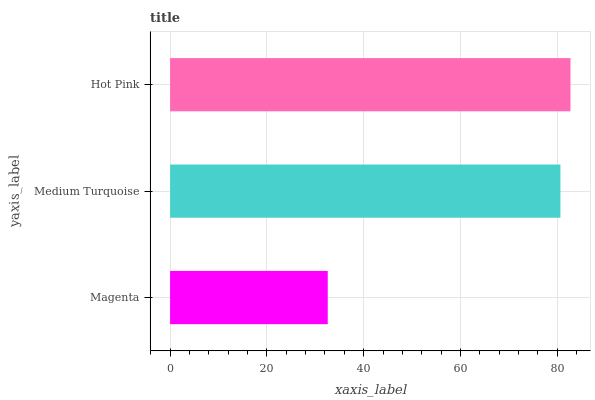Is Magenta the minimum?
Answer yes or no. Yes. Is Hot Pink the maximum?
Answer yes or no. Yes. Is Medium Turquoise the minimum?
Answer yes or no. No. Is Medium Turquoise the maximum?
Answer yes or no. No. Is Medium Turquoise greater than Magenta?
Answer yes or no. Yes. Is Magenta less than Medium Turquoise?
Answer yes or no. Yes. Is Magenta greater than Medium Turquoise?
Answer yes or no. No. Is Medium Turquoise less than Magenta?
Answer yes or no. No. Is Medium Turquoise the high median?
Answer yes or no. Yes. Is Medium Turquoise the low median?
Answer yes or no. Yes. Is Hot Pink the high median?
Answer yes or no. No. Is Hot Pink the low median?
Answer yes or no. No. 